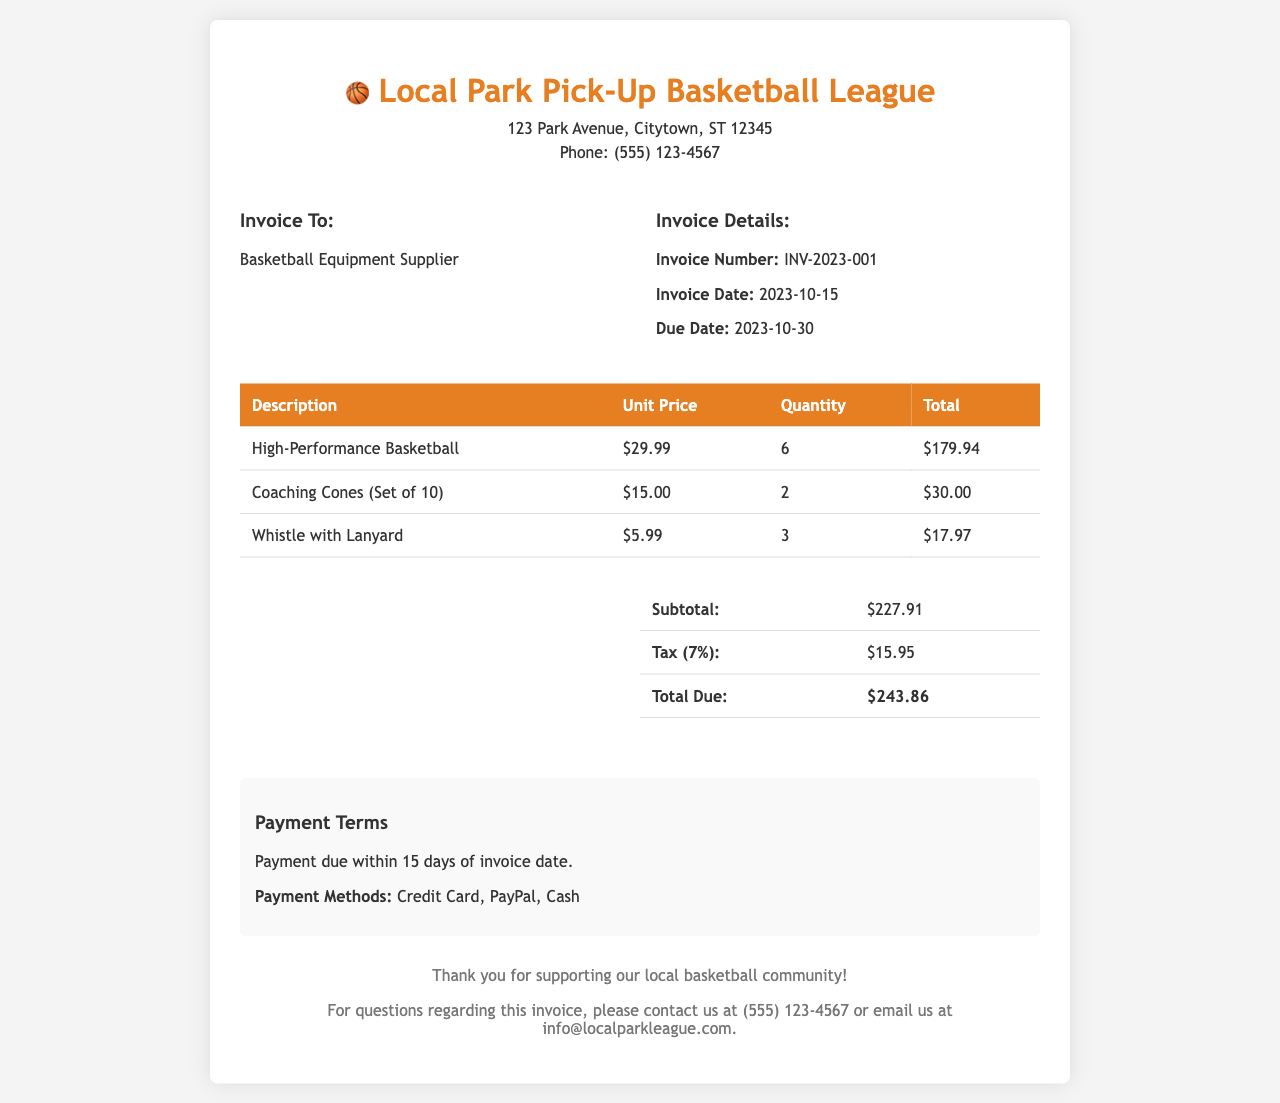What is the invoice number? The invoice number is provided in the invoice details section.
Answer: INV-2023-001 What is the total due amount? The total due amount is calculated by adding the subtotal and tax.
Answer: $243.86 How many high-performance basketballs were purchased? The quantity of high-performance basketballs is stated in the product list.
Answer: 6 What is the unit price of a coaching cone set? The unit price for the coaching cones is listed in the invoice table.
Answer: $15.00 What is the tax rate applied in this invoice? The tax rate can be found in the summary section of the invoice.
Answer: 7% What is the payment due date? The payment due date is indicated in the invoice details section.
Answer: 2023-10-30 Who is the invoice issued to? The recipient of the invoice is stated under the "Invoice To" section.
Answer: Basketball Equipment Supplier What payment methods are accepted? The accepted payment methods are listed in the payment terms section.
Answer: Credit Card, PayPal, Cash What is the subtotal amount before tax? The subtotal amount is provided in the summary table of the invoice.
Answer: $227.91 